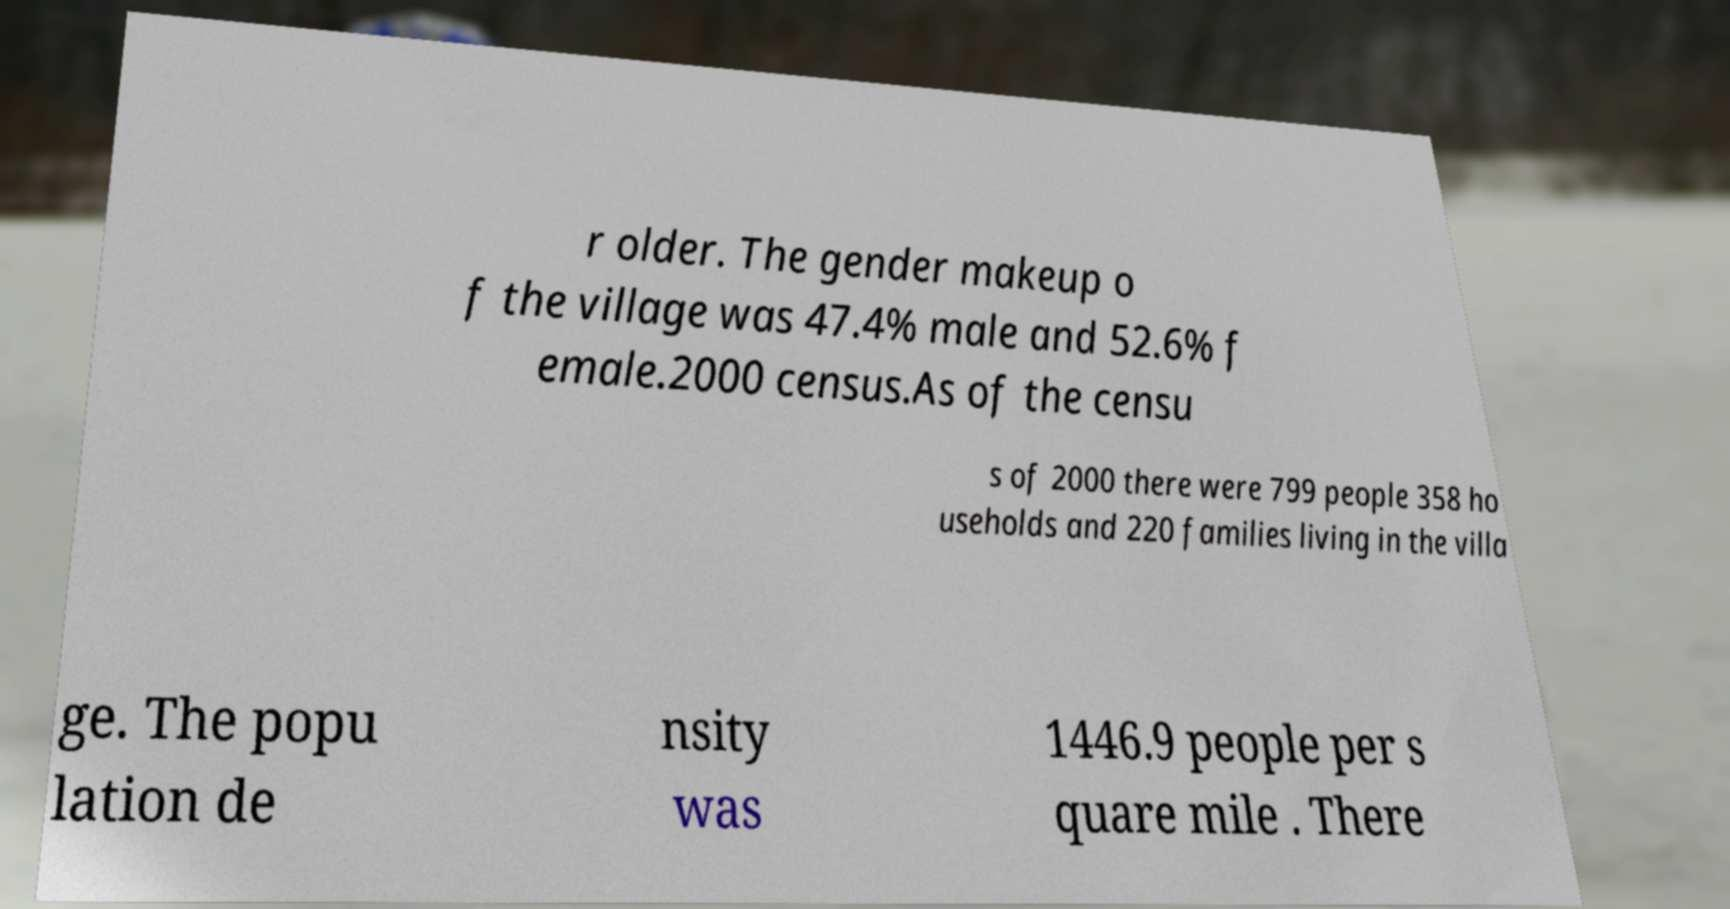I need the written content from this picture converted into text. Can you do that? r older. The gender makeup o f the village was 47.4% male and 52.6% f emale.2000 census.As of the censu s of 2000 there were 799 people 358 ho useholds and 220 families living in the villa ge. The popu lation de nsity was 1446.9 people per s quare mile . There 